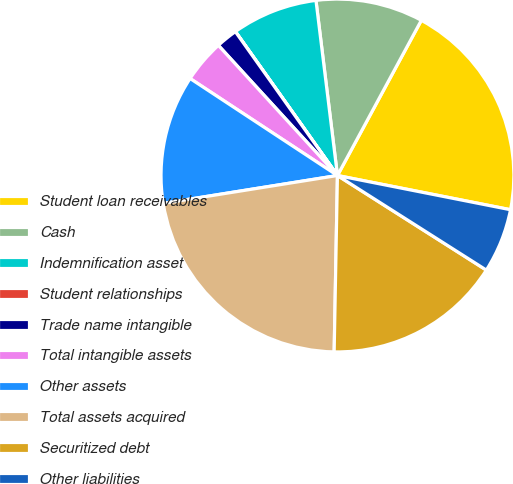Convert chart to OTSL. <chart><loc_0><loc_0><loc_500><loc_500><pie_chart><fcel>Student loan receivables<fcel>Cash<fcel>Indemnification asset<fcel>Student relationships<fcel>Trade name intangible<fcel>Total intangible assets<fcel>Other assets<fcel>Total assets acquired<fcel>Securitized debt<fcel>Other liabilities<nl><fcel>20.22%<fcel>9.83%<fcel>7.87%<fcel>0.01%<fcel>1.97%<fcel>3.94%<fcel>11.79%<fcel>22.18%<fcel>16.29%<fcel>5.9%<nl></chart> 